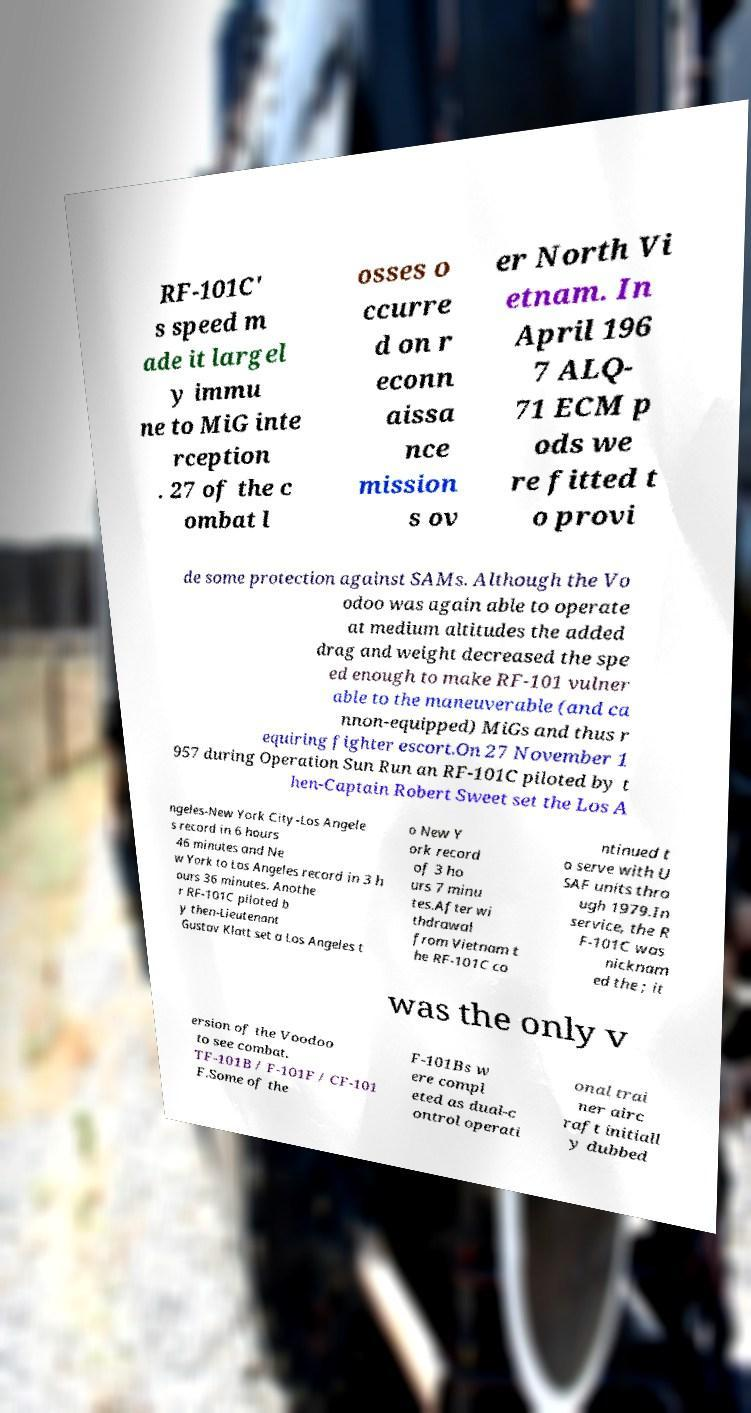Could you assist in decoding the text presented in this image and type it out clearly? RF-101C' s speed m ade it largel y immu ne to MiG inte rception . 27 of the c ombat l osses o ccurre d on r econn aissa nce mission s ov er North Vi etnam. In April 196 7 ALQ- 71 ECM p ods we re fitted t o provi de some protection against SAMs. Although the Vo odoo was again able to operate at medium altitudes the added drag and weight decreased the spe ed enough to make RF-101 vulner able to the maneuverable (and ca nnon-equipped) MiGs and thus r equiring fighter escort.On 27 November 1 957 during Operation Sun Run an RF-101C piloted by t hen-Captain Robert Sweet set the Los A ngeles-New York City-Los Angele s record in 6 hours 46 minutes and Ne w York to Los Angeles record in 3 h ours 36 minutes. Anothe r RF-101C piloted b y then-Lieutenant Gustav Klatt set a Los Angeles t o New Y ork record of 3 ho urs 7 minu tes.After wi thdrawal from Vietnam t he RF-101C co ntinued t o serve with U SAF units thro ugh 1979.In service, the R F-101C was nicknam ed the ; it was the only v ersion of the Voodoo to see combat. TF-101B / F-101F / CF-101 F.Some of the F-101Bs w ere compl eted as dual-c ontrol operati onal trai ner airc raft initiall y dubbed 